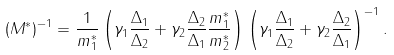<formula> <loc_0><loc_0><loc_500><loc_500>( M ^ { * } ) ^ { - 1 } = \frac { 1 } { m _ { 1 } ^ { * } } \left ( \gamma _ { 1 } \frac { \Delta _ { 1 } } { \Delta _ { 2 } } + \gamma _ { 2 } \frac { \Delta _ { 2 } } { \Delta _ { 1 } } \frac { m _ { 1 } ^ { * } } { m _ { 2 } ^ { * } } \right ) \left ( \gamma _ { 1 } \frac { \Delta _ { 1 } } { \Delta _ { 2 } } + \gamma _ { 2 } \frac { \Delta _ { 2 } } { \Delta _ { 1 } } \right ) ^ { - 1 } .</formula> 